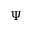Convert formula to latex. <formula><loc_0><loc_0><loc_500><loc_500>\Psi</formula> 